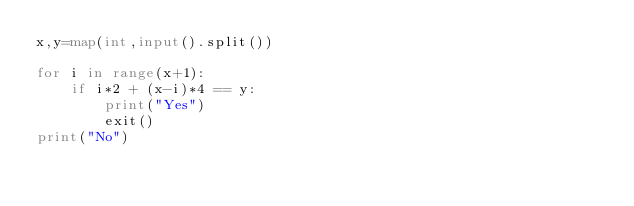<code> <loc_0><loc_0><loc_500><loc_500><_Python_>x,y=map(int,input().split())

for i in range(x+1):
    if i*2 + (x-i)*4 == y:
        print("Yes")
        exit()
print("No")</code> 